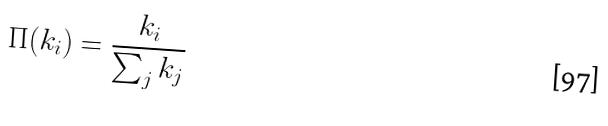Convert formula to latex. <formula><loc_0><loc_0><loc_500><loc_500>\Pi ( k _ { i } ) = \frac { k _ { i } } { \sum _ { j } k _ { j } }</formula> 